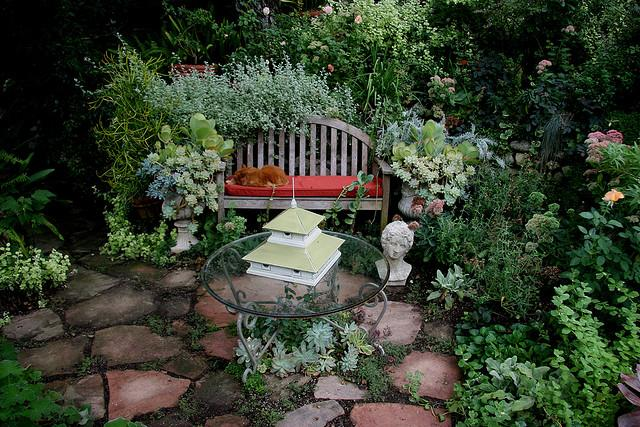What type of statue is to the right front of the bench?

Choices:
A) wooden
B) jade
C) bust
D) kinetic bust 